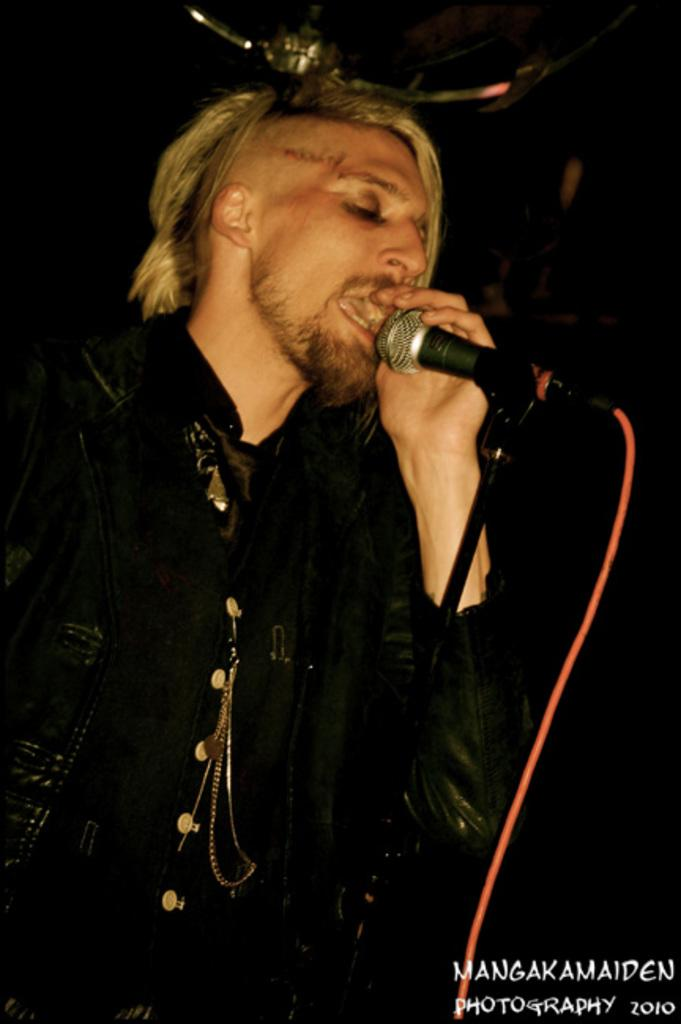What is the main subject of the image? The main subject of the image is a guy. What is the guy wearing in the image? The guy is wearing a black jacket in the image. What is the guy holding in the image? The guy is holding a microphone in the image. What is the guy doing in the image? The guy is singing a song in the image. What time is the discussion taking place in the image? There is no discussion taking place in the image, and therefore no specific time can be determined. 